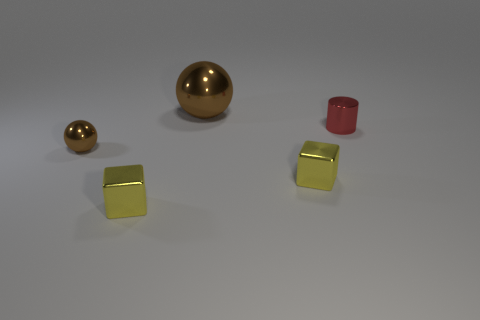There is a tiny ball; how many large brown shiny balls are left of it?
Keep it short and to the point. 0. Are there any blue metal things of the same size as the red thing?
Offer a very short reply. No. Do the large shiny sphere and the tiny ball have the same color?
Make the answer very short. Yes. The tiny metallic ball that is in front of the brown metal ball right of the tiny brown thing is what color?
Your response must be concise. Brown. What number of things are to the left of the red metal thing and in front of the large brown metal sphere?
Keep it short and to the point. 3. How many small brown metal objects are the same shape as the large metallic object?
Ensure brevity in your answer.  1. What is the shape of the small yellow object that is behind the yellow metal cube to the left of the big brown ball?
Your answer should be very brief. Cube. There is a large brown metal thing behind the tiny red shiny object; what number of cylinders are to the left of it?
Offer a very short reply. 0. What is the thing that is right of the big brown metallic sphere and in front of the red metallic thing made of?
Your answer should be compact. Metal. The brown thing that is the same size as the cylinder is what shape?
Offer a very short reply. Sphere. 